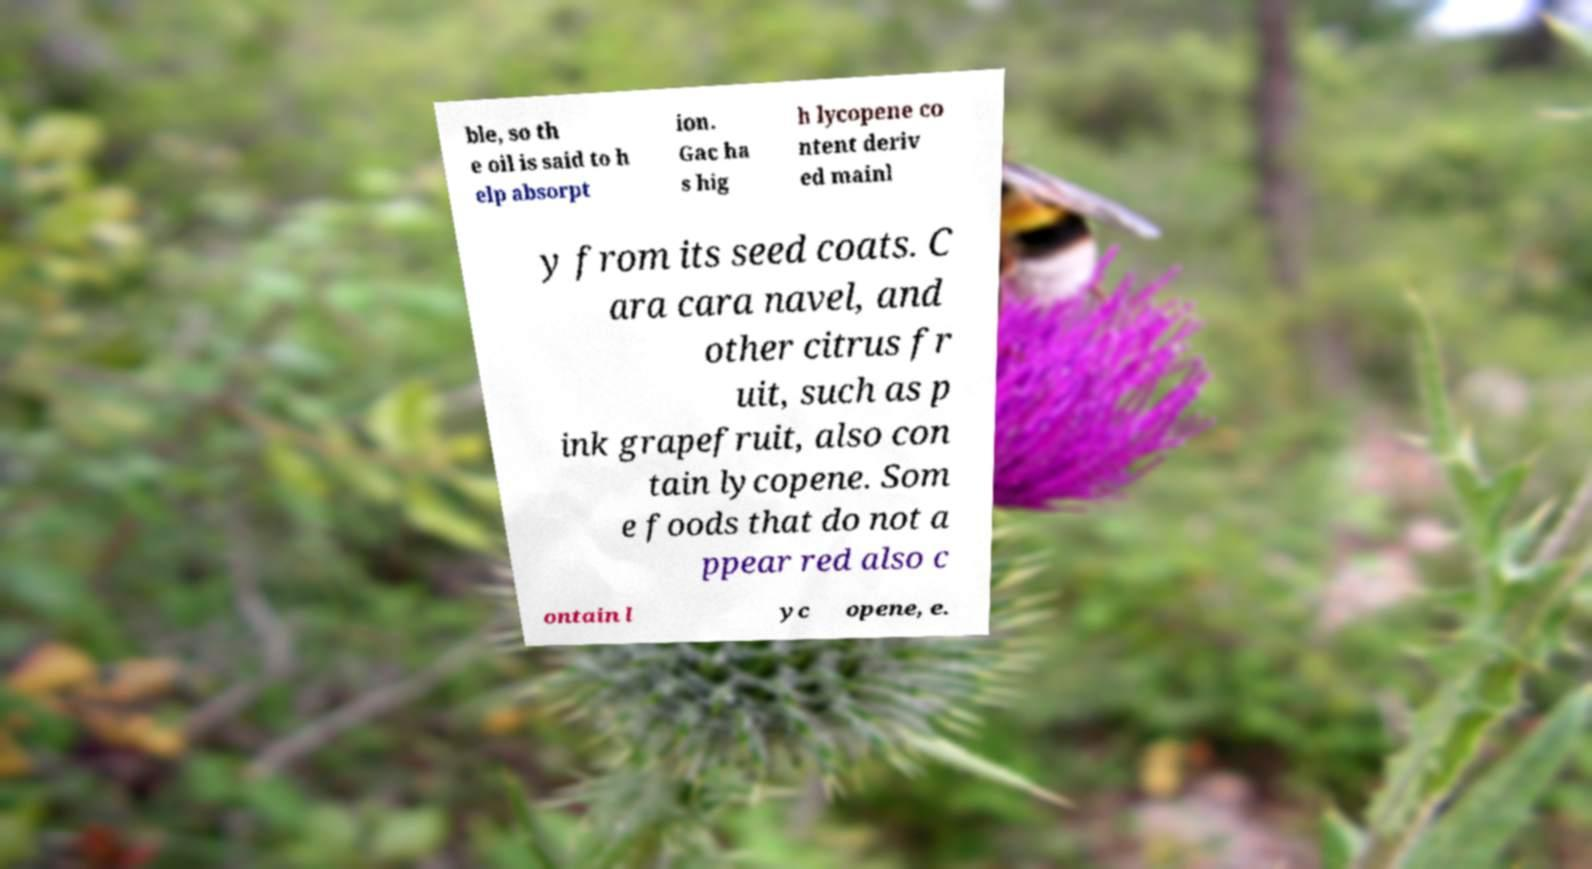Please identify and transcribe the text found in this image. ble, so th e oil is said to h elp absorpt ion. Gac ha s hig h lycopene co ntent deriv ed mainl y from its seed coats. C ara cara navel, and other citrus fr uit, such as p ink grapefruit, also con tain lycopene. Som e foods that do not a ppear red also c ontain l yc opene, e. 